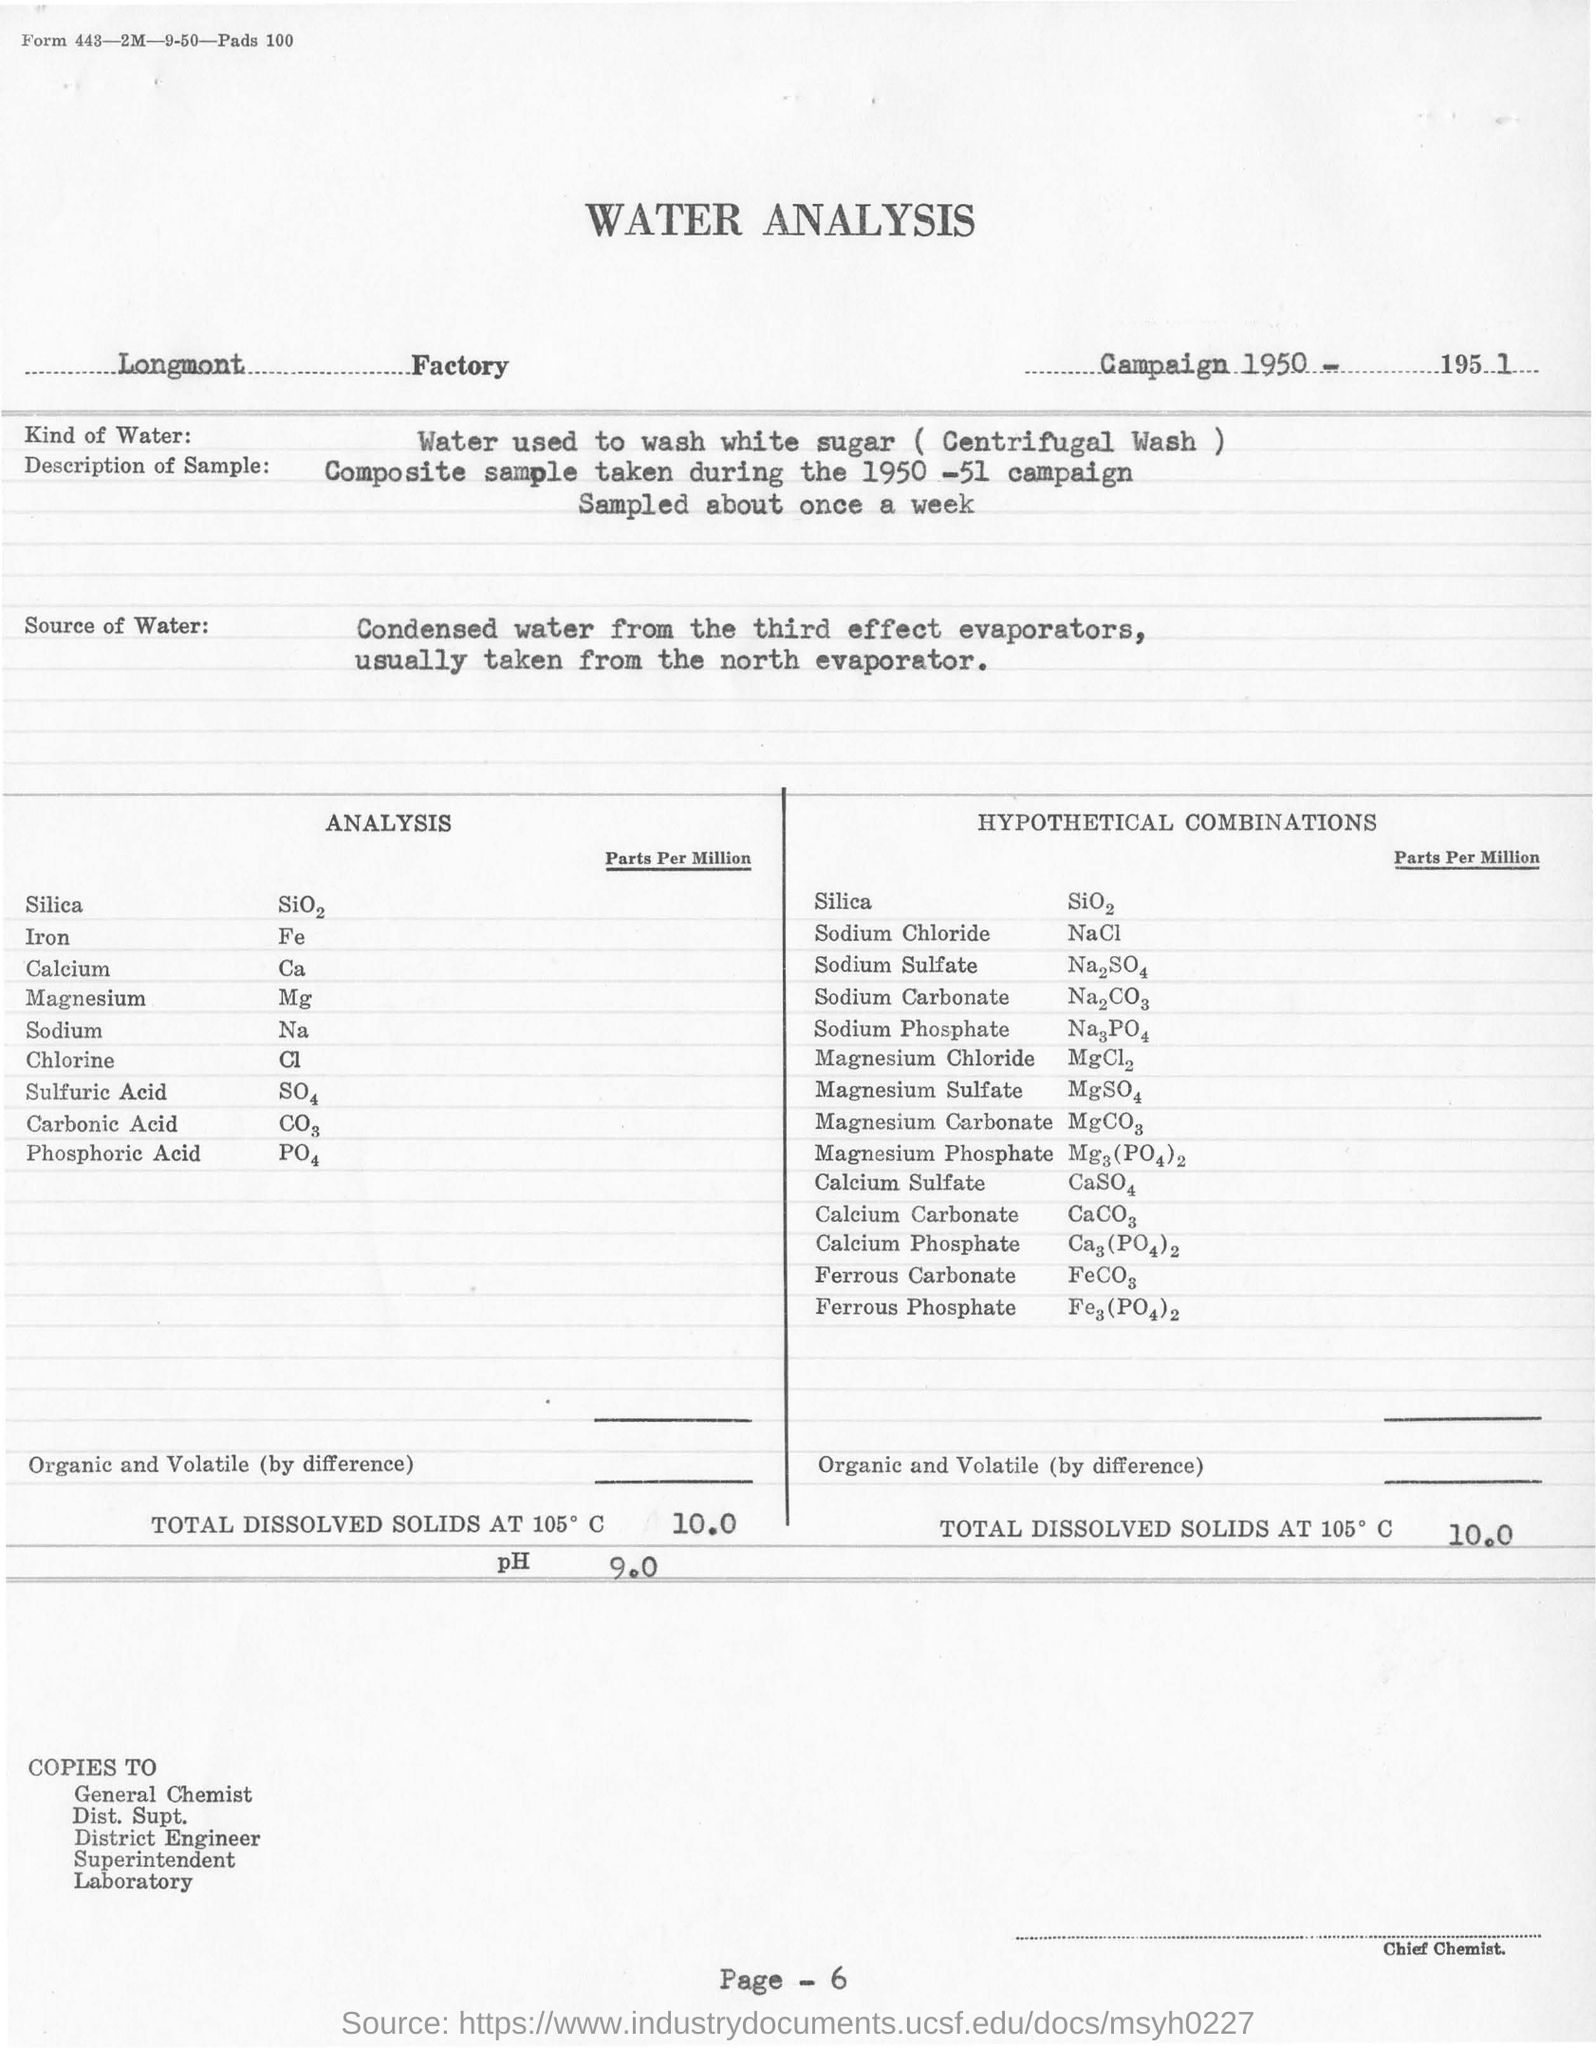What is the name of the factory ?
Your answer should be very brief. Longmont. In which year campaign was conducted?
Your answer should be very brief. Campaign 1950-1951. What is washed by water at longmont factory ?
Your response must be concise. White sugar. What kind of mechanism is used for washing white sugar?
Make the answer very short. Centrifugal wash. What is the frequency at which samples were taken?
Your answer should be compact. Once a week. From where the condensed is are taken for analysis?
Offer a terse response. The third effect evaporators. What is the ph value for the water sample taken from longmont factory?
Give a very brief answer. 9.0. What are the total dissolved solids at 105 degree c present in the hypothetical combinations?
Offer a very short reply. 10.0. Mention the first name who are going to receive the copies of water analysis?
Offer a terse response. General chemist. 